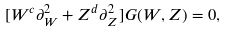Convert formula to latex. <formula><loc_0><loc_0><loc_500><loc_500>[ W ^ { c } \partial ^ { 2 } _ { W } + Z ^ { d } \partial ^ { 2 } _ { Z } ] G ( W , Z ) = 0 ,</formula> 